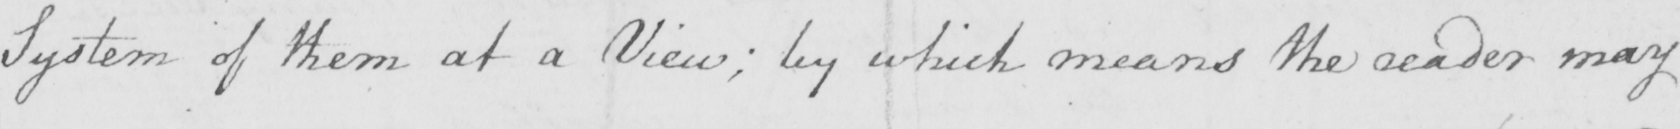Transcribe the text shown in this historical manuscript line. System of them at a View ; by which means the reader may 